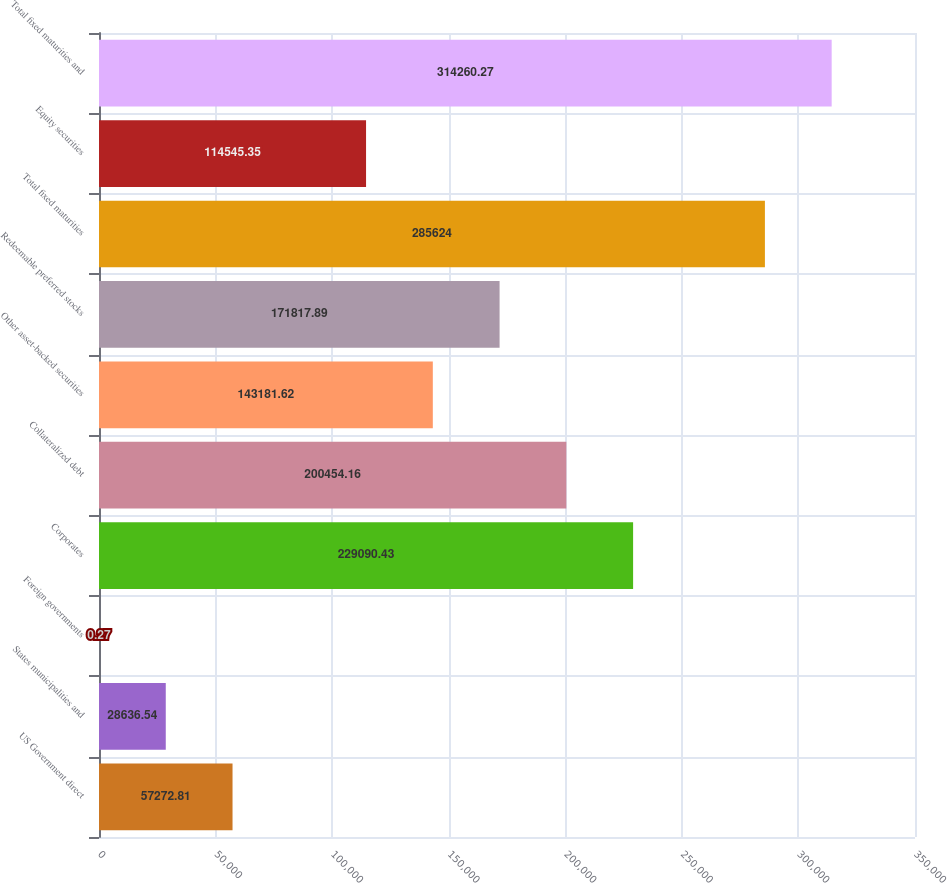Convert chart to OTSL. <chart><loc_0><loc_0><loc_500><loc_500><bar_chart><fcel>US Government direct<fcel>States municipalities and<fcel>Foreign governments<fcel>Corporates<fcel>Collateralized debt<fcel>Other asset-backed securities<fcel>Redeemable preferred stocks<fcel>Total fixed maturities<fcel>Equity securities<fcel>Total fixed maturities and<nl><fcel>57272.8<fcel>28636.5<fcel>0.27<fcel>229090<fcel>200454<fcel>143182<fcel>171818<fcel>285624<fcel>114545<fcel>314260<nl></chart> 